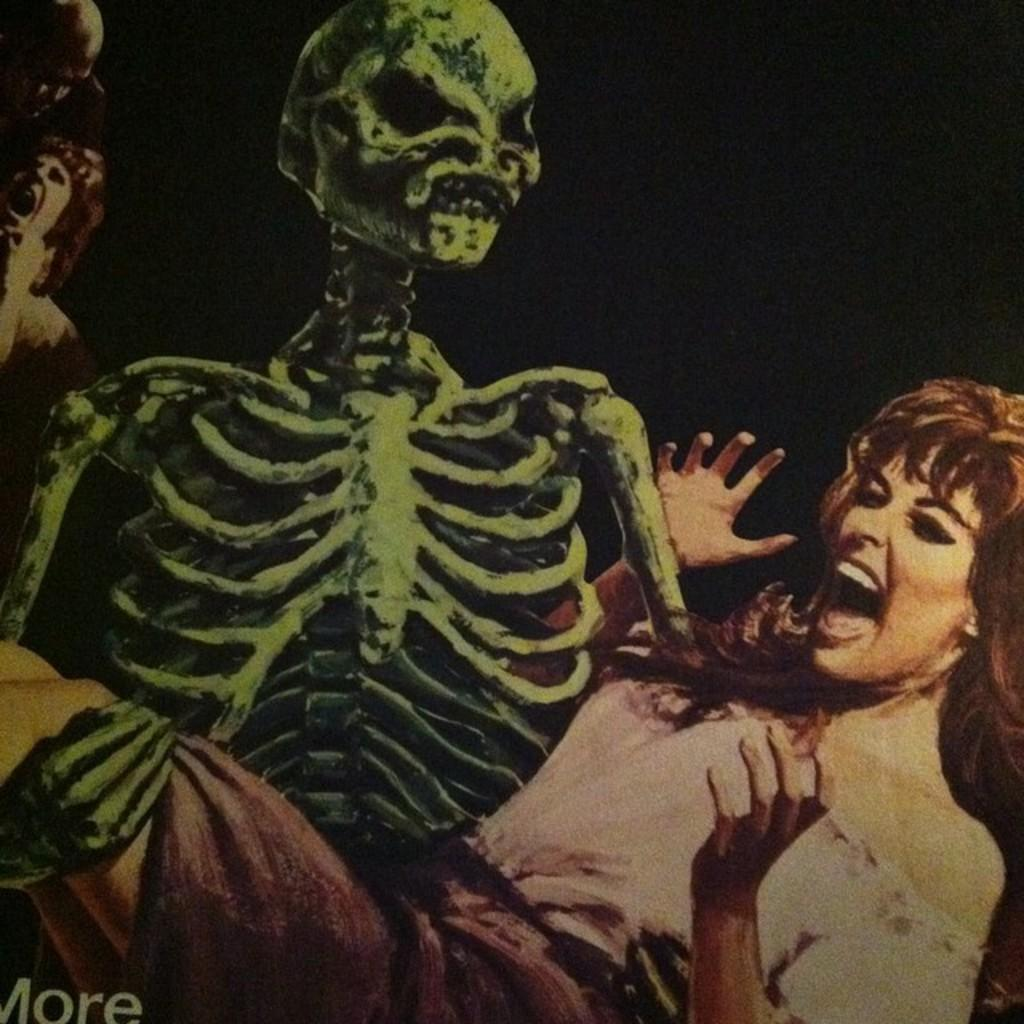What is the main subject of the painting? The painting depicts a skeleton holding a woman. Can you describe any other figures in the painting? There are two persons in the background of the painting. What is the color of the background in the painting? The background color is dark. What color is the woman's desire in the painting? There is no indication of the woman's desire in the painting, and therefore no color can be assigned to it. 